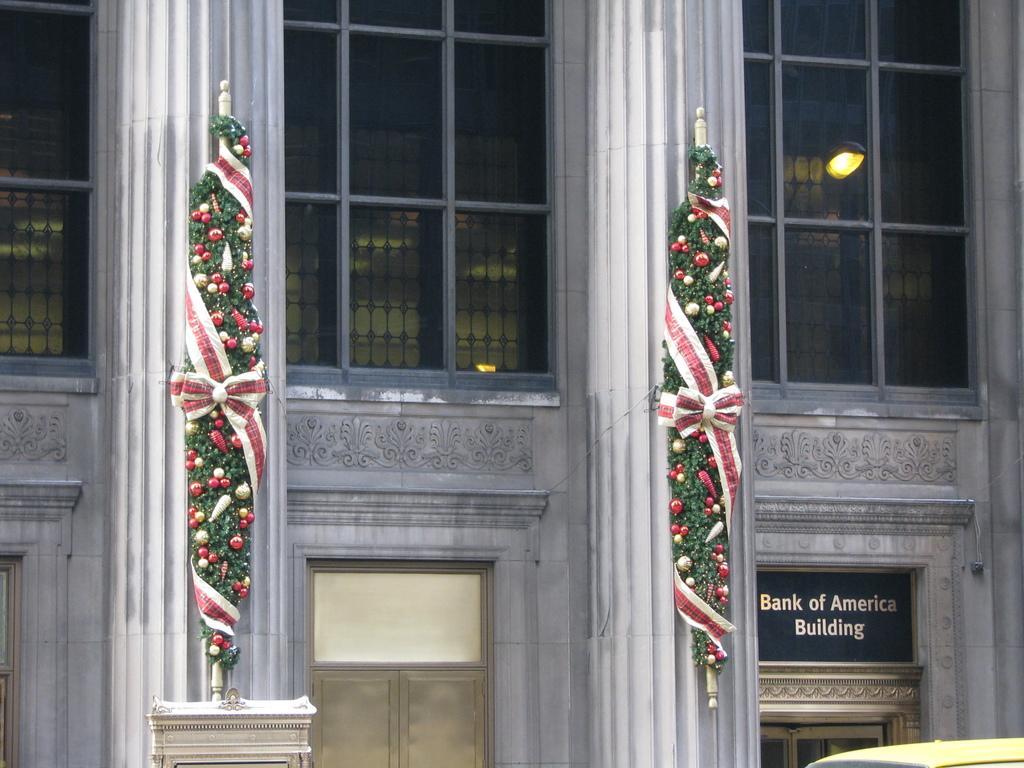Please provide a concise description of this image. In this image in front there is a building and in front of the building there are two pillars decorated. 